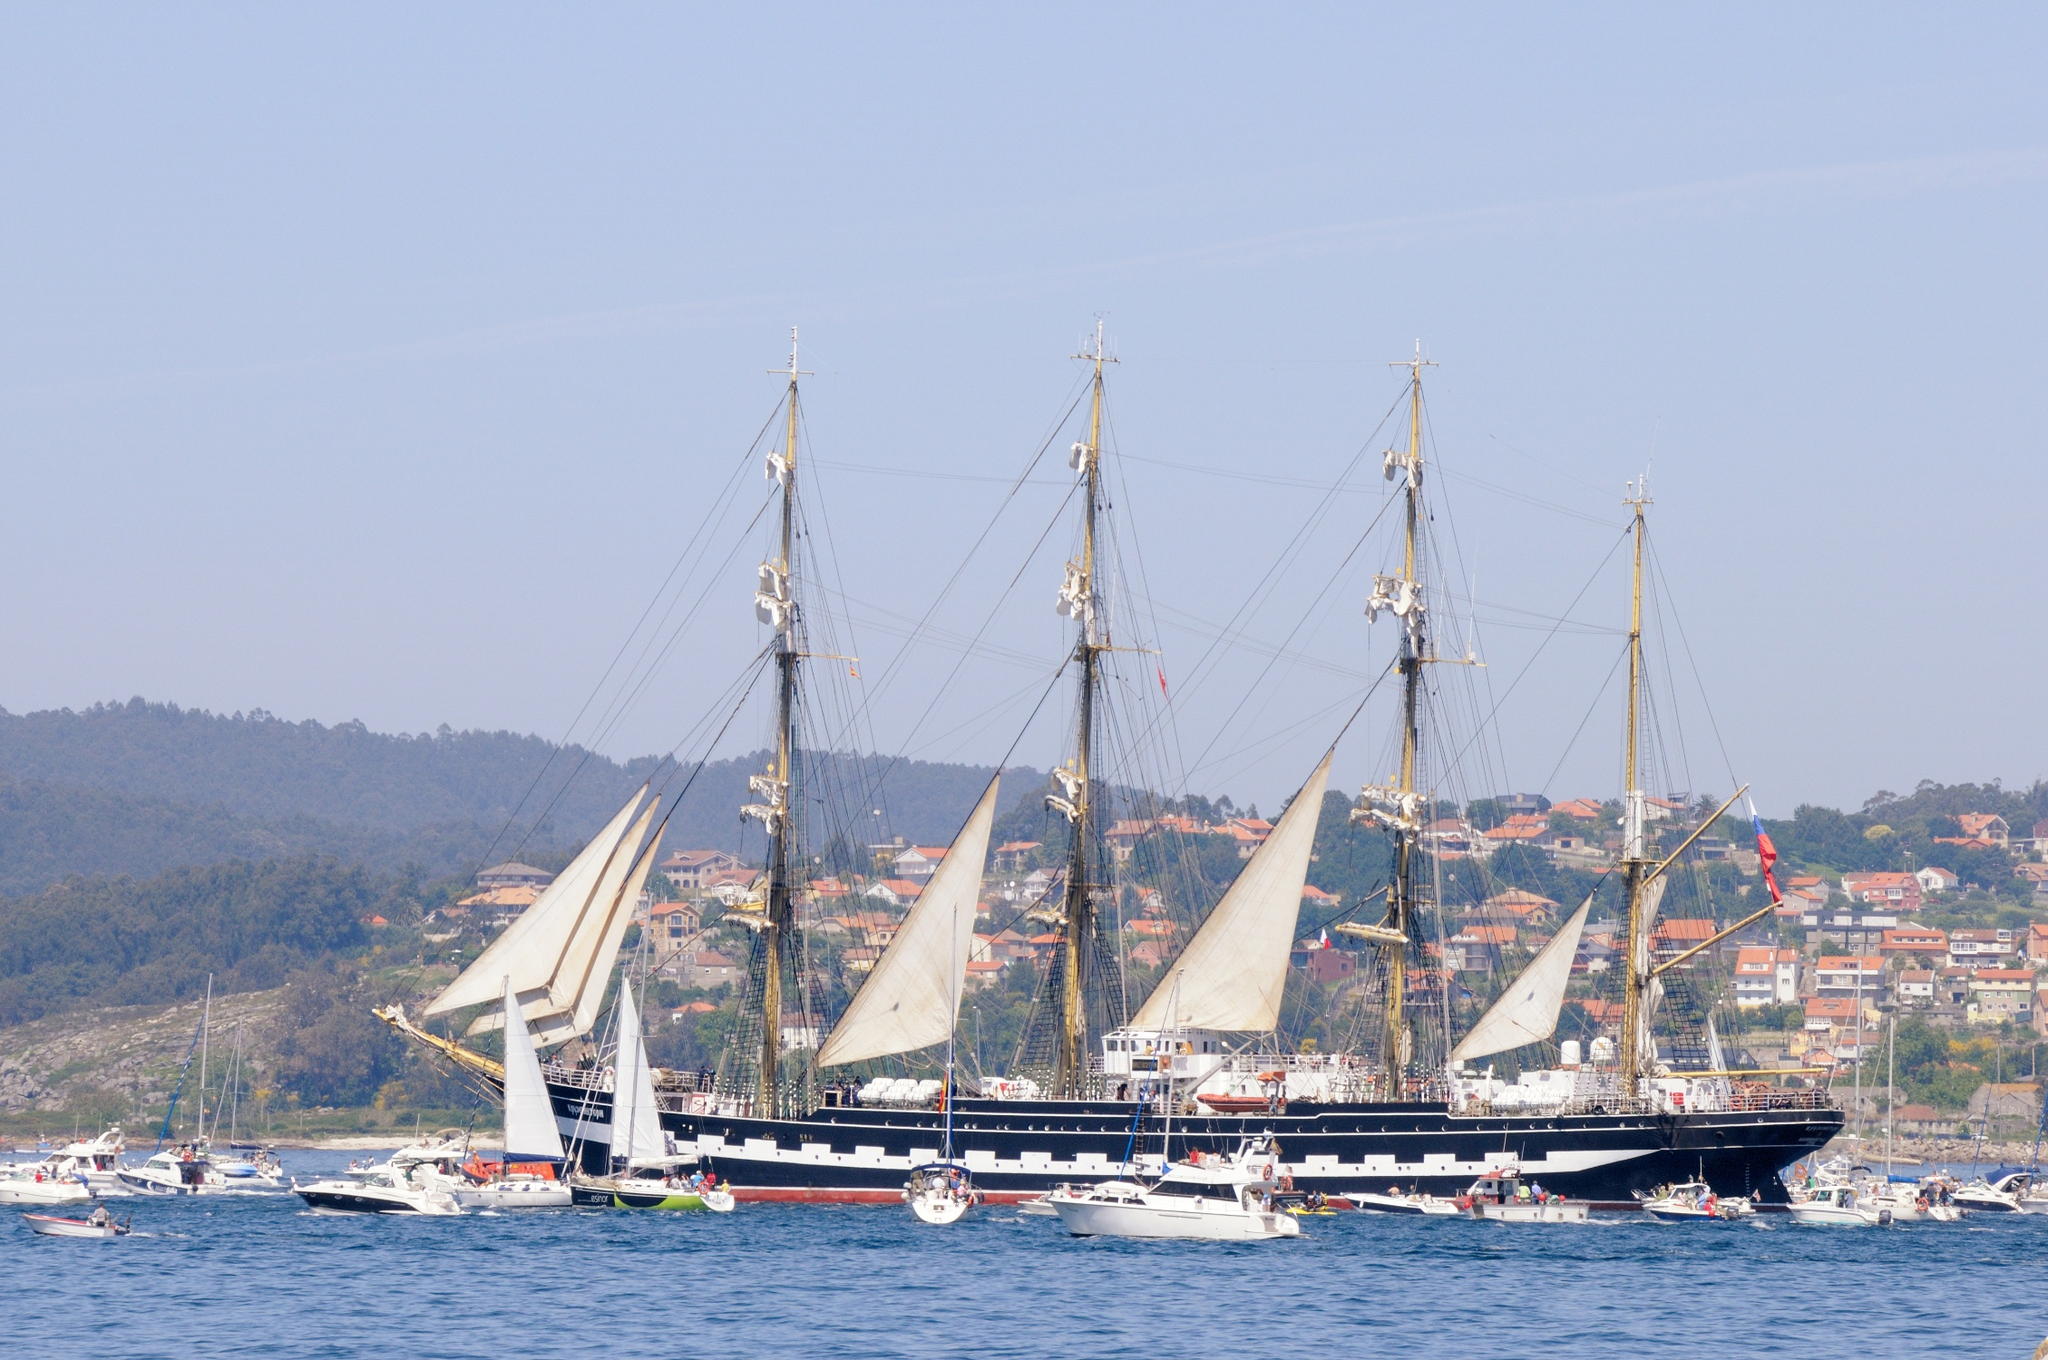What could be the significance of the town visible in the background? The town in the background, with its waterfront proximity and the presence of a large sailing ship, suggests a deep connection with maritime activities. It could be a coastal community with a historical link to the sea, possibly with a local economy that still relies heavily on the boating industry, tourism, or fishing. The architecture and natural setting indicate it may be a scenic destination celebrated for its cultural and nautical heritage. 